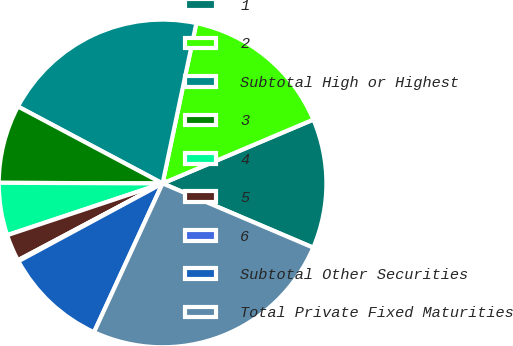<chart> <loc_0><loc_0><loc_500><loc_500><pie_chart><fcel>1<fcel>2<fcel>Subtotal High or Highest<fcel>3<fcel>4<fcel>5<fcel>6<fcel>Subtotal Other Securities<fcel>Total Private Fixed Maturities<nl><fcel>12.79%<fcel>15.32%<fcel>20.53%<fcel>7.72%<fcel>5.18%<fcel>2.65%<fcel>0.11%<fcel>10.25%<fcel>25.46%<nl></chart> 